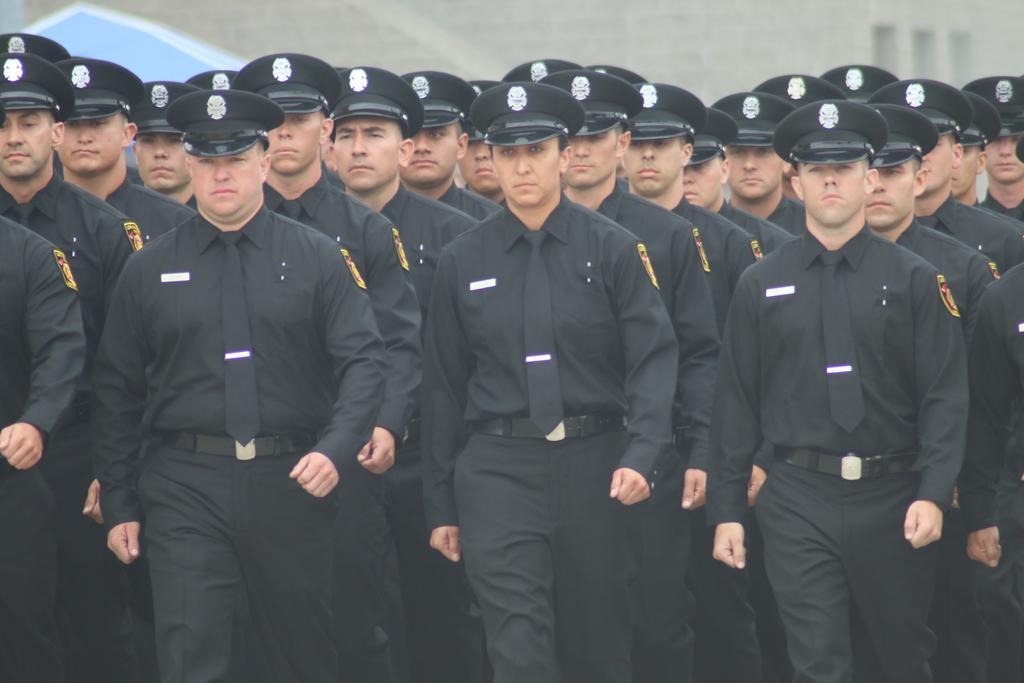Can you describe this image briefly? The picture consists of soldiers in black uniforms marching. In the background there is a building. The soldiers are wearing black hats. 